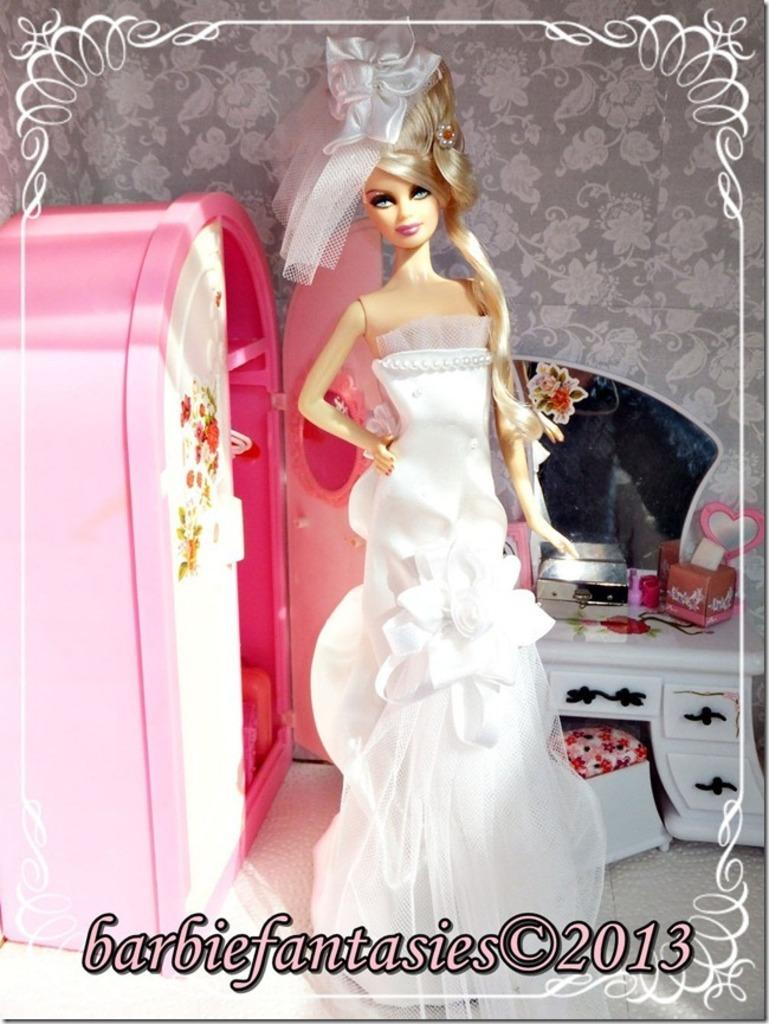What type of objects can be seen in the image? There are toys in the image, including a doll. Can you describe the table in the image? The table has a mirror on it. What color is prominent in the image? There are pink color objects in the image. What is the background of the image? There is a wall in the image. Is there any text present in the image? Yes, there is some text at the bottom of the image. What type of sound does the thunder make in the image? There is no thunder present in the image; it is a still image without any sound. 